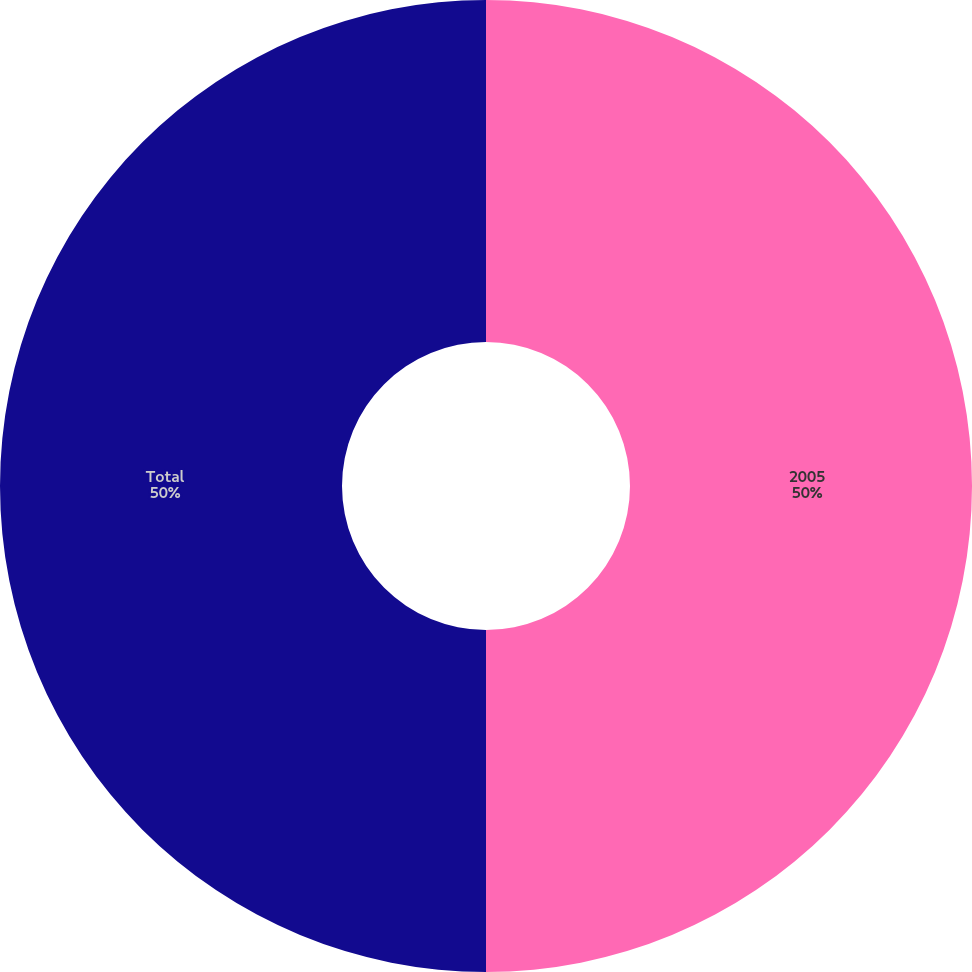Convert chart. <chart><loc_0><loc_0><loc_500><loc_500><pie_chart><fcel>2005<fcel>Total<nl><fcel>50.0%<fcel>50.0%<nl></chart> 